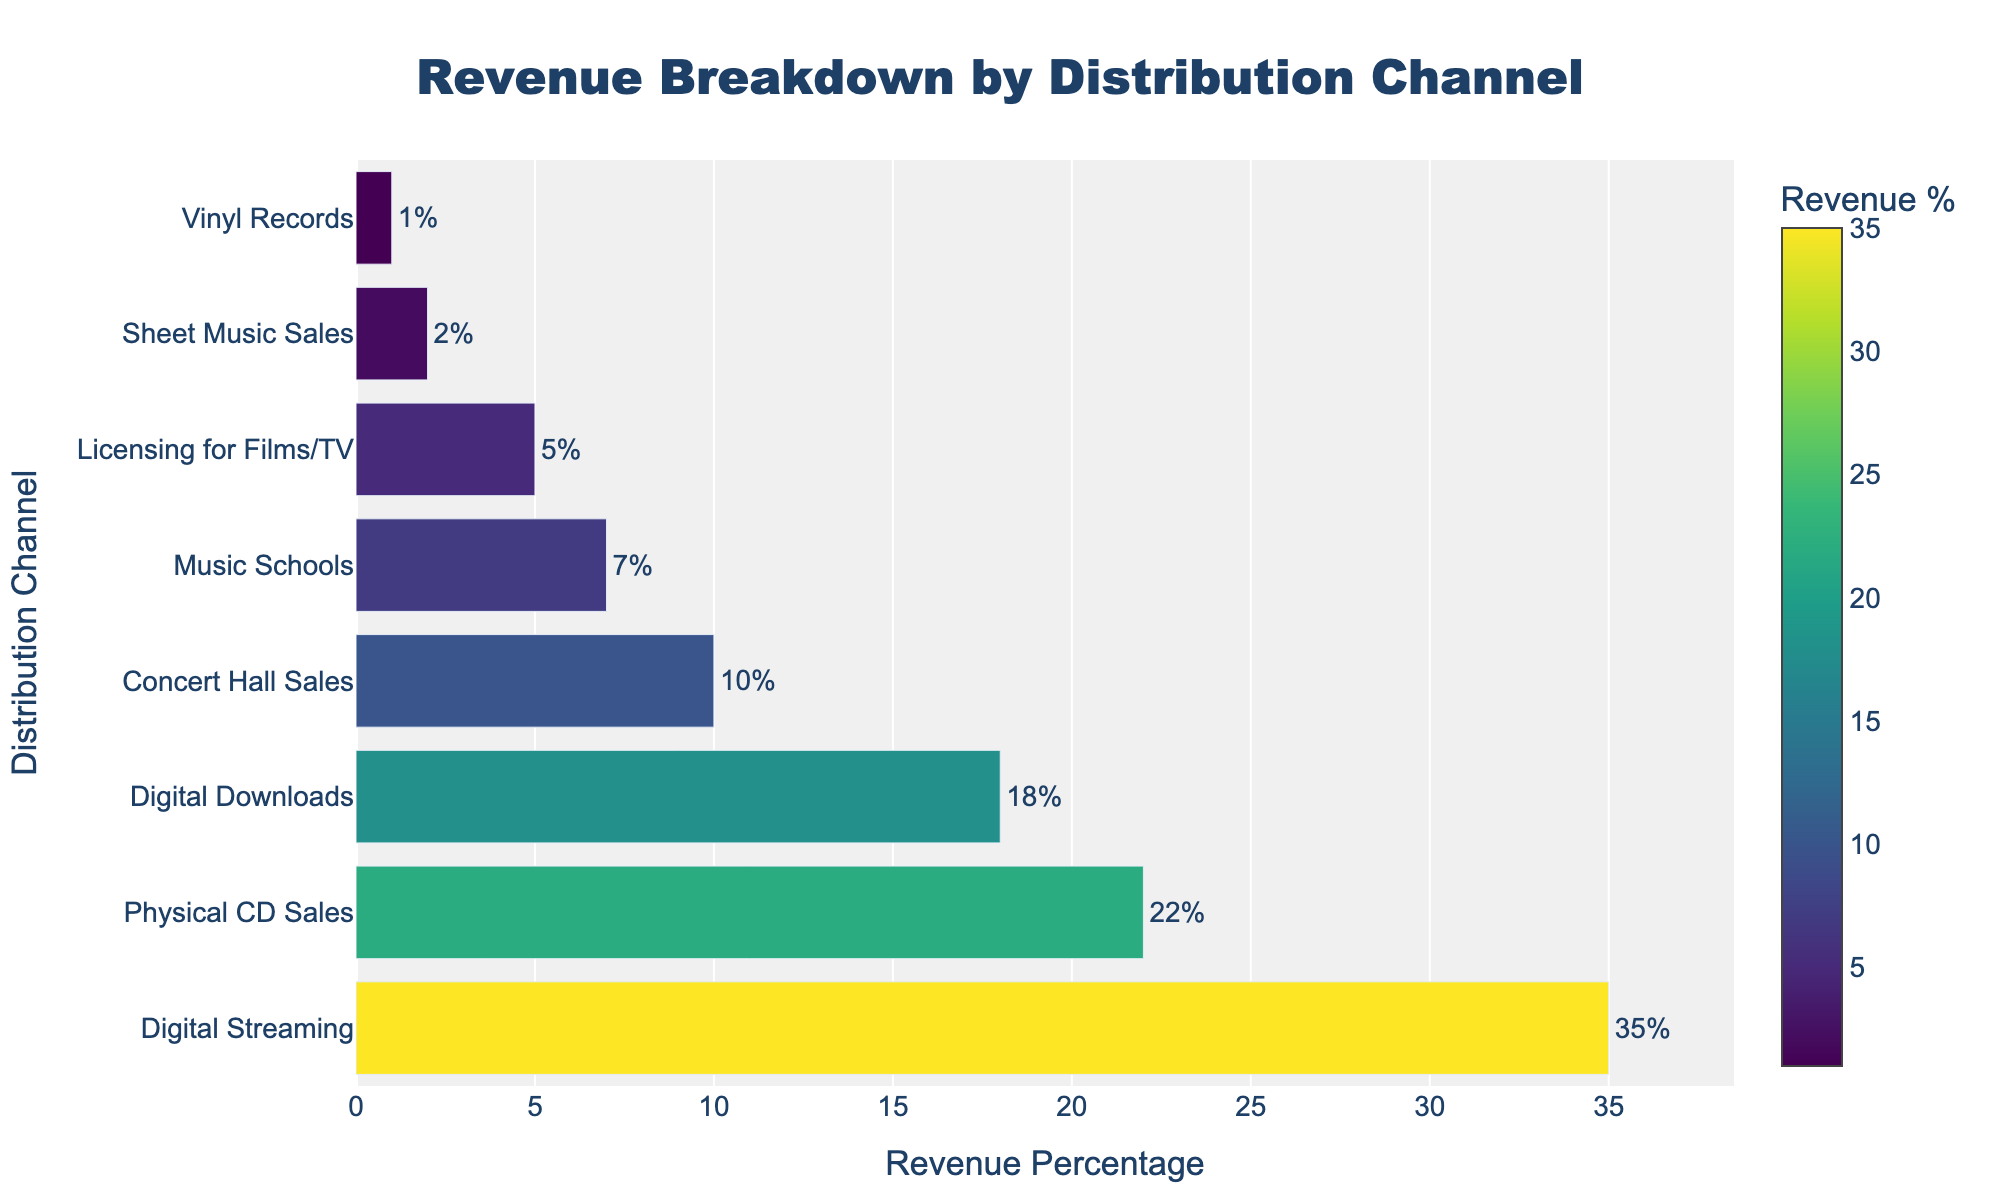What's the revenue percentage from Digital Streaming? Locate the bar labeled 'Digital Streaming'. The text on the bar says '35%', representing the revenue percentage.
Answer: 35% What is the combined revenue percentage of Digital Downloads and Physical CD Sales? Find the bars labeled 'Digital Downloads' and 'Physical CD Sales'. The percentages are 18% and 22% respectively. Add these two values together: 18 + 22 = 40.
Answer: 40% Which distribution channel contributes the least to the revenue? Identify the bar with the smallest text outside it. The bar corresponding to 'Vinyl Records' has the smallest percentage at 1%.
Answer: Vinyl Records Compare the revenue percentages of Music Schools and Concert Hall Sales. Which one is higher and by how much? Locate the bars for 'Music Schools' and 'Concert Hall Sales'. The percentages are 7% and 10% respectively. Subtract the smaller value from the larger one: 10 - 7 = 3. Concert Hall Sales has a higher revenue percentage by 3%.
Answer: Concert Hall Sales by 3% What is the total revenue percentage from non-digital channels? Sum the percentages of non-digital channels: Physical CD Sales (22%), Concert Hall Sales (10%), Music Schools (7%), Licensing for Films/TV (5%), Sheet Music Sales (2%), and Vinyl Records (1%). Total = 22 + 10 + 7 + 5 + 2 + 1 = 47.
Answer: 47% What is the average revenue percentage of all distribution channels? Sum all the revenue percentages: 35 + 22 + 18 + 10 + 7 + 5 + 2 + 1 = 100. There are 8 channels, so the average is 100 / 8 = 12.5.
Answer: 12.5 What is the difference in revenue percentage between the top channel and the third-highest channel? The top channel is 'Digital Streaming' at 35%, and the third-highest is 'Digital Downloads' at 18%. The difference is 35 - 18 = 17.
Answer: 17 Which distribution channels have a revenue percentage greater than 15%? Identify the bars with text indicating percentages greater than 15%. These are 'Digital Streaming' (35%), 'Physical CD Sales' (22%), and 'Digital Downloads' (18%).
Answer: Digital Streaming, Physical CD Sales, Digital Downloads Which distribution channel color appears most intense on the plot? Analyze the color intensity of the bars. The highest revenue percentage is 'Digital Streaming' at 35%, meaning it will have the most intense color.
Answer: Digital Streaming 